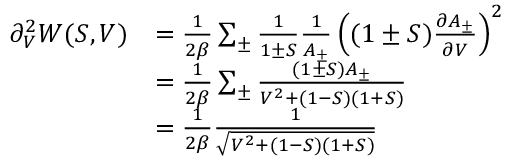<formula> <loc_0><loc_0><loc_500><loc_500>\begin{array} { r l } { \partial _ { V } ^ { 2 } W ( S , V ) } & { = \frac { 1 } { 2 \beta } \sum _ { \pm } \frac { 1 } { 1 \pm S } \frac { 1 } { A _ { \pm } } \left ( ( 1 \pm S ) \frac { \partial A _ { \pm } } { \partial V } \right ) ^ { 2 } } \\ & { = \frac { 1 } { 2 \beta } \sum _ { \pm } \frac { ( 1 \pm S ) A _ { \pm } } { V ^ { 2 } + ( 1 - S ) ( 1 + S ) } } \\ & { = \frac { 1 } { 2 \beta } \frac { 1 } { \sqrt { V ^ { 2 } + ( 1 - S ) ( 1 + S ) } } } \end{array}</formula> 